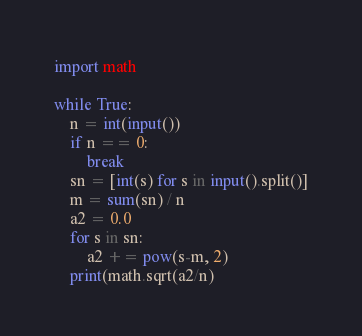<code> <loc_0><loc_0><loc_500><loc_500><_Python_>import math

while True:
    n = int(input())
    if n == 0:
        break
    sn = [int(s) for s in input().split()]
    m = sum(sn) / n
    a2 = 0.0
    for s in sn:
        a2 += pow(s-m, 2)
    print(math.sqrt(a2/n)</code> 